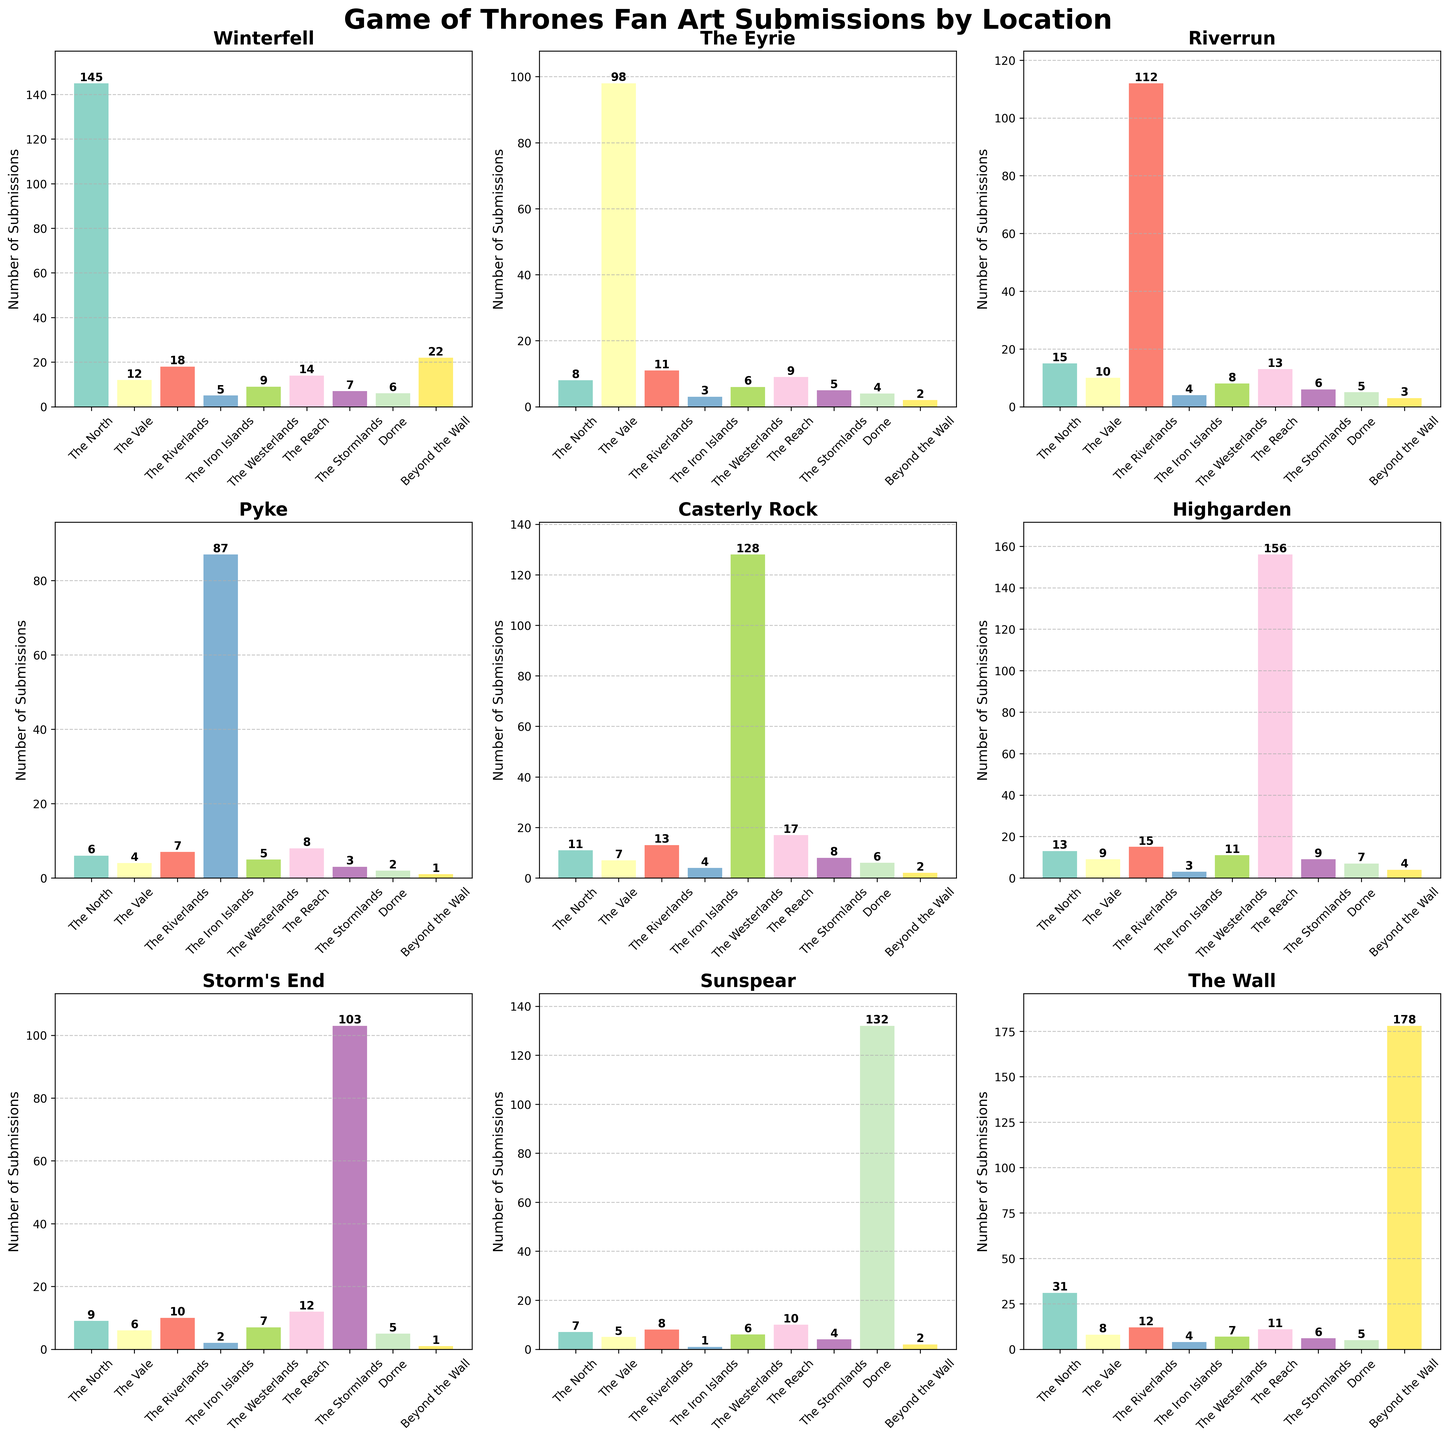What's the sum of fan art submissions for Winterfell and The Eyrie? To find the sum, add the fan art submissions for Winterfell (145) and The Eyrie (8): 145 + 8 = 153.
Answer: 153 Which location in The Reach has the highest number of fan art submissions? By looking at the plot for The Reach, we can see that Highgarden has the highest number of fan art submissions, which is 156.
Answer: Highgarden Are there more fan art submissions for Riverrun or Casterly Rock in The Riverlands? Comparing the bars in The Riverlands subplot for Riverrun (112) and Casterly Rock (128), Casterly Rock has more submissions.
Answer: Casterly Rock What is the difference in fan art submissions between Pyke and Highgarden in The Reach? Subtract the number of submissions for Pyke (87) from the submissions for Highgarden (156): 156 - 87 = 69.
Answer: 69 In which region does Storm’s End have more fan art submissions compared to other locations? By assessing the subplot for The Stormlands, it is evident that Storm’s End has the most submissions with 103.
Answer: The Stormlands What is the average number of fan art submissions for all locations in The North? To find the average, sum the submissions for all locations in The North (Winterfell: 145, The Eyrie: 8, Riverrun: 15, Pyke: 6, Casterly Rock: 11, Highgarden: 13, Storm's End: 9, Sunspear: 7, and The Wall: 31), which is 245. Then, divide by the number of locations (9): 245 / 9 ≈ 27.22.
Answer: 27.22 Does Beyond the Wall have more submissions for The Wall or Winterfell? By examining the Beyond the Wall subplot, The Wall has 178 submissions and Winterfell has 22 submissions, so The Wall has more.
Answer: The Wall What is the color of the highest bar in the Sunspear region? Observing the Sunspear subplot, the highest bar represents Sunspear with 132 submissions and is colored with the designated shade from the colormap used.
Answer: The specific shade from the colormap (visual inspection needed) Which bar is the tallest among all the plots? By comparing the heights of all the bars across the subplots, the tallest bar is The Wall in the Beyond the Wall region with 178 submissions.
Answer: The Wall in Beyond the Wall Which region has the least number of fan art submissions for Pyke? By looking at the Pyke subplot, Dorne has the least submissions with just 2.
Answer: Dorne 